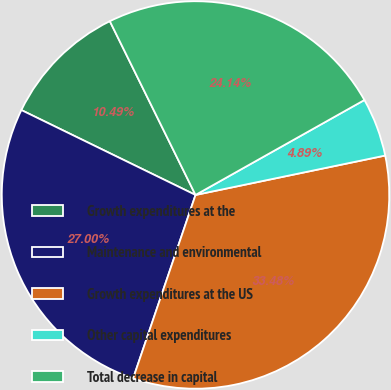<chart> <loc_0><loc_0><loc_500><loc_500><pie_chart><fcel>Growth expenditures at the<fcel>Maintenance and environmental<fcel>Growth expenditures at the US<fcel>Other capital expenditures<fcel>Total decrease in capital<nl><fcel>10.49%<fcel>27.0%<fcel>33.48%<fcel>4.89%<fcel>24.14%<nl></chart> 